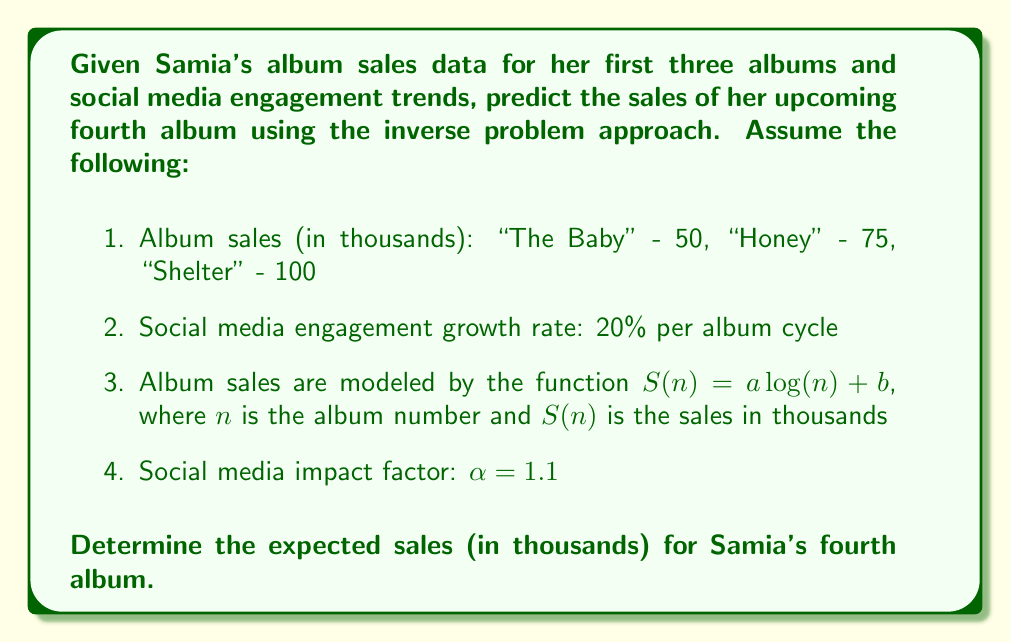Could you help me with this problem? To solve this inverse problem and predict Samia's fourth album sales, we'll follow these steps:

1. First, we need to determine the parameters $a$ and $b$ in the sales model $S(n) = a \log(n) + b$ using the given data for the first three albums.

2. We'll use the first and third album data points to create a system of equations:
   $$50 = a \log(1) + b$$
   $$100 = a \log(3) + b$$

3. Simplify the first equation:
   $$50 = b$$ (since $\log(1) = 0$)

4. Substitute $b = 50$ into the second equation:
   $$100 = a \log(3) + 50$$
   $$50 = a \log(3)$$
   $$a = \frac{50}{\log(3)} \approx 45.49$$

5. Now we have our sales model:
   $$S(n) = 45.49 \log(n) + 50$$

6. Calculate the predicted sales for the fourth album without considering social media growth:
   $$S(4) = 45.49 \log(4) + 50 \approx 113.21$$

7. Account for social media engagement growth:
   - Growth rate: 20% per album cycle
   - Total growth: $(1 + 0.2)^3 = 1.728$ (over three album cycles)

8. Apply the social media impact factor $\alpha$:
   $$S_{adjusted}(4) = S(4) \cdot \alpha \cdot 1.728$$
   $$S_{adjusted}(4) = 113.21 \cdot 1.1 \cdot 1.728 \approx 215.15$$

Therefore, the expected sales for Samia's fourth album, considering both the sales trend and social media growth, is approximately 215.15 thousand units.
Answer: 215.15 thousand units 